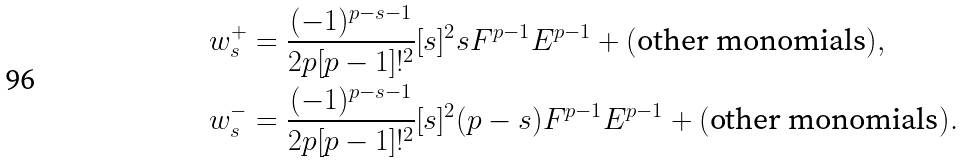Convert formula to latex. <formula><loc_0><loc_0><loc_500><loc_500>w _ { s } ^ { + } & = \frac { ( - 1 ) ^ { p - s - 1 } } { 2 p [ p - 1 ] ! ^ { 2 } } [ s ] ^ { 2 } s F ^ { p - 1 } E ^ { p - 1 } + ( \text {other monomials} ) , \\ w _ { s } ^ { - } & = \frac { ( - 1 ) ^ { p - s - 1 } } { 2 p [ p - 1 ] ! ^ { 2 } } [ s ] ^ { 2 } ( p - s ) F ^ { p - 1 } E ^ { p - 1 } + ( \text {other monomials} ) .</formula> 